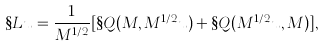<formula> <loc_0><loc_0><loc_500><loc_500>\S L u = \frac { 1 } { M ^ { 1 / 2 } } [ \S Q ( M , M ^ { 1 / 2 } u ) + \S Q ( M ^ { 1 / 2 } u , M ) ] ,</formula> 